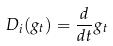Convert formula to latex. <formula><loc_0><loc_0><loc_500><loc_500>D _ { i } ( g _ { t } ) = \frac { d } { d t } g _ { t }</formula> 